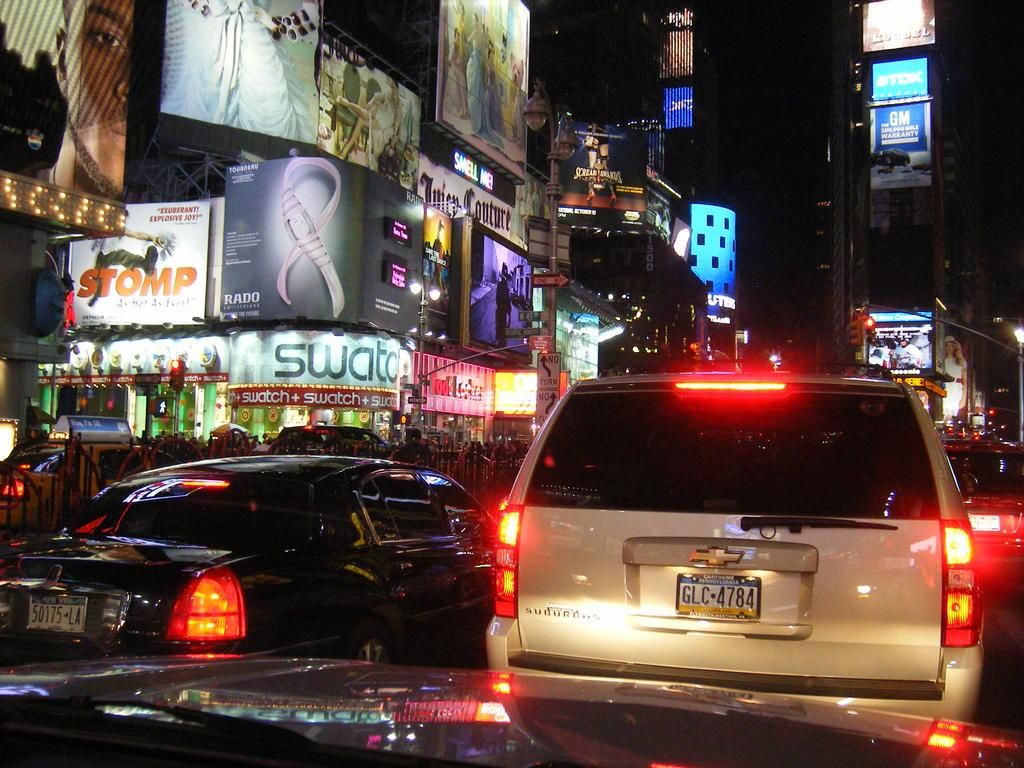<image>
Relay a brief, clear account of the picture shown. The van is from the state of Pennsylvania 